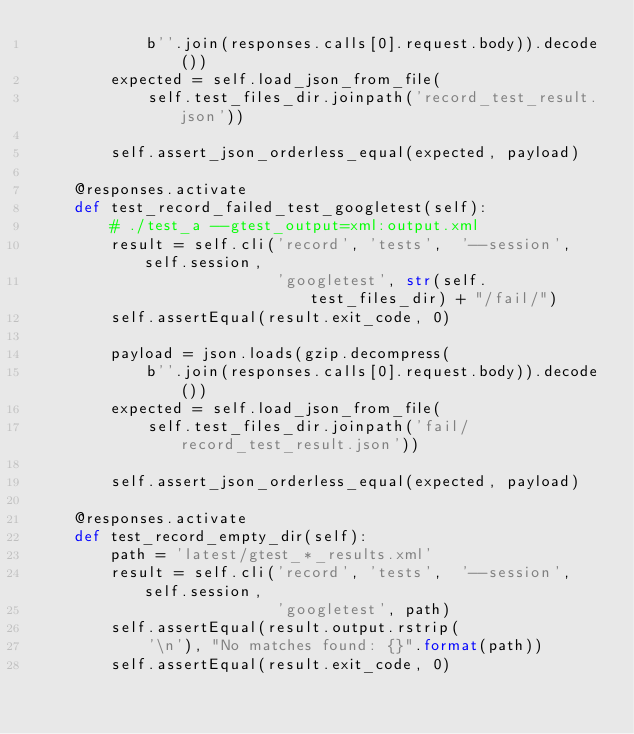Convert code to text. <code><loc_0><loc_0><loc_500><loc_500><_Python_>            b''.join(responses.calls[0].request.body)).decode())
        expected = self.load_json_from_file(
            self.test_files_dir.joinpath('record_test_result.json'))

        self.assert_json_orderless_equal(expected, payload)

    @responses.activate
    def test_record_failed_test_googletest(self):
        # ./test_a --gtest_output=xml:output.xml
        result = self.cli('record', 'tests',  '--session', self.session,
                          'googletest', str(self.test_files_dir) + "/fail/")
        self.assertEqual(result.exit_code, 0)

        payload = json.loads(gzip.decompress(
            b''.join(responses.calls[0].request.body)).decode())
        expected = self.load_json_from_file(
            self.test_files_dir.joinpath('fail/record_test_result.json'))

        self.assert_json_orderless_equal(expected, payload)

    @responses.activate
    def test_record_empty_dir(self):
        path = 'latest/gtest_*_results.xml'
        result = self.cli('record', 'tests',  '--session', self.session,
                          'googletest', path)
        self.assertEqual(result.output.rstrip(
            '\n'), "No matches found: {}".format(path))
        self.assertEqual(result.exit_code, 0)
</code> 